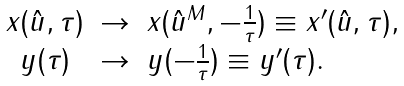Convert formula to latex. <formula><loc_0><loc_0><loc_500><loc_500>\begin{array} { c c l } x ( \hat { u } , \tau ) & \rightarrow & x ( \hat { u } ^ { M } , - \frac { 1 } { \tau } ) \equiv x ^ { \prime } ( \hat { u } , \tau ) , \\ y ( \tau ) & \rightarrow & y ( - \frac { 1 } { \tau } ) \equiv y ^ { \prime } ( \tau ) . \end{array}</formula> 